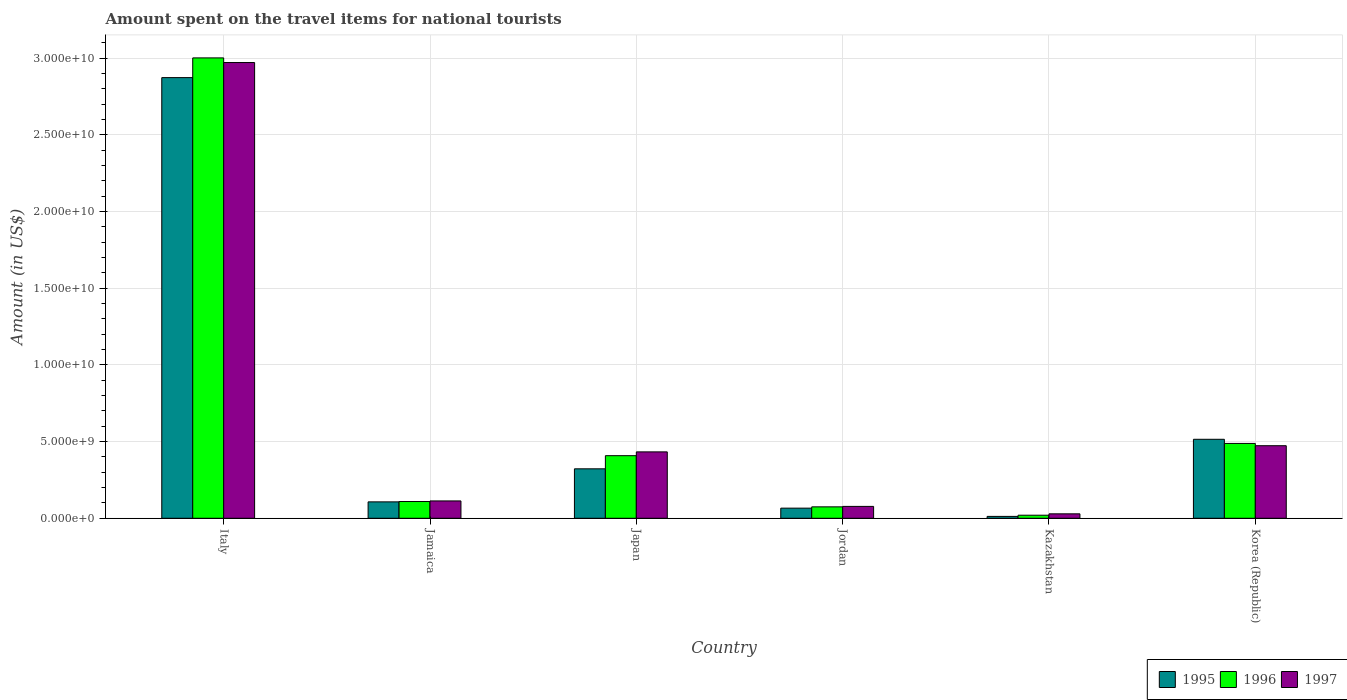How many different coloured bars are there?
Your response must be concise. 3. How many groups of bars are there?
Ensure brevity in your answer.  6. What is the label of the 5th group of bars from the left?
Keep it short and to the point. Kazakhstan. What is the amount spent on the travel items for national tourists in 1997 in Korea (Republic)?
Offer a very short reply. 4.73e+09. Across all countries, what is the maximum amount spent on the travel items for national tourists in 1997?
Provide a succinct answer. 2.97e+1. Across all countries, what is the minimum amount spent on the travel items for national tourists in 1997?
Make the answer very short. 2.89e+08. In which country was the amount spent on the travel items for national tourists in 1996 minimum?
Provide a succinct answer. Kazakhstan. What is the total amount spent on the travel items for national tourists in 1997 in the graph?
Offer a very short reply. 4.10e+1. What is the difference between the amount spent on the travel items for national tourists in 1996 in Italy and that in Japan?
Your response must be concise. 2.59e+1. What is the difference between the amount spent on the travel items for national tourists in 1997 in Kazakhstan and the amount spent on the travel items for national tourists in 1996 in Korea (Republic)?
Keep it short and to the point. -4.59e+09. What is the average amount spent on the travel items for national tourists in 1997 per country?
Offer a very short reply. 6.83e+09. What is the difference between the amount spent on the travel items for national tourists of/in 1997 and amount spent on the travel items for national tourists of/in 1996 in Kazakhstan?
Provide a short and direct response. 9.00e+07. What is the ratio of the amount spent on the travel items for national tourists in 1996 in Jamaica to that in Korea (Republic)?
Offer a terse response. 0.22. Is the amount spent on the travel items for national tourists in 1996 in Italy less than that in Kazakhstan?
Your response must be concise. No. Is the difference between the amount spent on the travel items for national tourists in 1997 in Kazakhstan and Korea (Republic) greater than the difference between the amount spent on the travel items for national tourists in 1996 in Kazakhstan and Korea (Republic)?
Give a very brief answer. Yes. What is the difference between the highest and the second highest amount spent on the travel items for national tourists in 1997?
Your answer should be very brief. 2.54e+1. What is the difference between the highest and the lowest amount spent on the travel items for national tourists in 1996?
Your answer should be compact. 2.98e+1. In how many countries, is the amount spent on the travel items for national tourists in 1995 greater than the average amount spent on the travel items for national tourists in 1995 taken over all countries?
Offer a very short reply. 1. What does the 1st bar from the right in Italy represents?
Keep it short and to the point. 1997. How many bars are there?
Your response must be concise. 18. What is the difference between two consecutive major ticks on the Y-axis?
Offer a very short reply. 5.00e+09. Are the values on the major ticks of Y-axis written in scientific E-notation?
Offer a very short reply. Yes. Does the graph contain any zero values?
Offer a terse response. No. Does the graph contain grids?
Offer a terse response. Yes. How many legend labels are there?
Ensure brevity in your answer.  3. What is the title of the graph?
Provide a short and direct response. Amount spent on the travel items for national tourists. What is the label or title of the X-axis?
Your answer should be very brief. Country. What is the Amount (in US$) of 1995 in Italy?
Ensure brevity in your answer.  2.87e+1. What is the Amount (in US$) in 1996 in Italy?
Give a very brief answer. 3.00e+1. What is the Amount (in US$) in 1997 in Italy?
Offer a very short reply. 2.97e+1. What is the Amount (in US$) of 1995 in Jamaica?
Give a very brief answer. 1.07e+09. What is the Amount (in US$) in 1996 in Jamaica?
Ensure brevity in your answer.  1.09e+09. What is the Amount (in US$) of 1997 in Jamaica?
Provide a short and direct response. 1.13e+09. What is the Amount (in US$) in 1995 in Japan?
Provide a short and direct response. 3.22e+09. What is the Amount (in US$) of 1996 in Japan?
Make the answer very short. 4.08e+09. What is the Amount (in US$) of 1997 in Japan?
Make the answer very short. 4.33e+09. What is the Amount (in US$) in 1995 in Jordan?
Ensure brevity in your answer.  6.60e+08. What is the Amount (in US$) in 1996 in Jordan?
Your answer should be compact. 7.44e+08. What is the Amount (in US$) of 1997 in Jordan?
Your response must be concise. 7.74e+08. What is the Amount (in US$) of 1995 in Kazakhstan?
Provide a succinct answer. 1.22e+08. What is the Amount (in US$) in 1996 in Kazakhstan?
Give a very brief answer. 1.99e+08. What is the Amount (in US$) in 1997 in Kazakhstan?
Keep it short and to the point. 2.89e+08. What is the Amount (in US$) in 1995 in Korea (Republic)?
Offer a very short reply. 5.15e+09. What is the Amount (in US$) of 1996 in Korea (Republic)?
Offer a terse response. 4.88e+09. What is the Amount (in US$) of 1997 in Korea (Republic)?
Provide a short and direct response. 4.73e+09. Across all countries, what is the maximum Amount (in US$) of 1995?
Your answer should be compact. 2.87e+1. Across all countries, what is the maximum Amount (in US$) of 1996?
Offer a very short reply. 3.00e+1. Across all countries, what is the maximum Amount (in US$) in 1997?
Make the answer very short. 2.97e+1. Across all countries, what is the minimum Amount (in US$) of 1995?
Offer a terse response. 1.22e+08. Across all countries, what is the minimum Amount (in US$) in 1996?
Make the answer very short. 1.99e+08. Across all countries, what is the minimum Amount (in US$) of 1997?
Ensure brevity in your answer.  2.89e+08. What is the total Amount (in US$) in 1995 in the graph?
Make the answer very short. 3.90e+1. What is the total Amount (in US$) of 1996 in the graph?
Your response must be concise. 4.10e+1. What is the total Amount (in US$) of 1997 in the graph?
Offer a very short reply. 4.10e+1. What is the difference between the Amount (in US$) of 1995 in Italy and that in Jamaica?
Keep it short and to the point. 2.77e+1. What is the difference between the Amount (in US$) of 1996 in Italy and that in Jamaica?
Offer a very short reply. 2.89e+1. What is the difference between the Amount (in US$) of 1997 in Italy and that in Jamaica?
Provide a short and direct response. 2.86e+1. What is the difference between the Amount (in US$) in 1995 in Italy and that in Japan?
Offer a terse response. 2.55e+1. What is the difference between the Amount (in US$) in 1996 in Italy and that in Japan?
Provide a succinct answer. 2.59e+1. What is the difference between the Amount (in US$) of 1997 in Italy and that in Japan?
Keep it short and to the point. 2.54e+1. What is the difference between the Amount (in US$) in 1995 in Italy and that in Jordan?
Provide a succinct answer. 2.81e+1. What is the difference between the Amount (in US$) in 1996 in Italy and that in Jordan?
Your response must be concise. 2.93e+1. What is the difference between the Amount (in US$) of 1997 in Italy and that in Jordan?
Give a very brief answer. 2.89e+1. What is the difference between the Amount (in US$) of 1995 in Italy and that in Kazakhstan?
Keep it short and to the point. 2.86e+1. What is the difference between the Amount (in US$) of 1996 in Italy and that in Kazakhstan?
Provide a succinct answer. 2.98e+1. What is the difference between the Amount (in US$) of 1997 in Italy and that in Kazakhstan?
Your answer should be very brief. 2.94e+1. What is the difference between the Amount (in US$) of 1995 in Italy and that in Korea (Republic)?
Provide a succinct answer. 2.36e+1. What is the difference between the Amount (in US$) in 1996 in Italy and that in Korea (Republic)?
Your answer should be very brief. 2.51e+1. What is the difference between the Amount (in US$) of 1997 in Italy and that in Korea (Republic)?
Ensure brevity in your answer.  2.50e+1. What is the difference between the Amount (in US$) in 1995 in Jamaica and that in Japan?
Offer a very short reply. -2.16e+09. What is the difference between the Amount (in US$) in 1996 in Jamaica and that in Japan?
Give a very brief answer. -2.99e+09. What is the difference between the Amount (in US$) in 1997 in Jamaica and that in Japan?
Give a very brief answer. -3.20e+09. What is the difference between the Amount (in US$) in 1995 in Jamaica and that in Jordan?
Give a very brief answer. 4.09e+08. What is the difference between the Amount (in US$) in 1996 in Jamaica and that in Jordan?
Make the answer very short. 3.48e+08. What is the difference between the Amount (in US$) in 1997 in Jamaica and that in Jordan?
Ensure brevity in your answer.  3.57e+08. What is the difference between the Amount (in US$) in 1995 in Jamaica and that in Kazakhstan?
Offer a terse response. 9.47e+08. What is the difference between the Amount (in US$) of 1996 in Jamaica and that in Kazakhstan?
Ensure brevity in your answer.  8.93e+08. What is the difference between the Amount (in US$) of 1997 in Jamaica and that in Kazakhstan?
Give a very brief answer. 8.42e+08. What is the difference between the Amount (in US$) in 1995 in Jamaica and that in Korea (Republic)?
Provide a short and direct response. -4.08e+09. What is the difference between the Amount (in US$) in 1996 in Jamaica and that in Korea (Republic)?
Your answer should be compact. -3.79e+09. What is the difference between the Amount (in US$) of 1997 in Jamaica and that in Korea (Republic)?
Your answer should be very brief. -3.60e+09. What is the difference between the Amount (in US$) in 1995 in Japan and that in Jordan?
Offer a very short reply. 2.56e+09. What is the difference between the Amount (in US$) in 1996 in Japan and that in Jordan?
Your response must be concise. 3.34e+09. What is the difference between the Amount (in US$) of 1997 in Japan and that in Jordan?
Your response must be concise. 3.56e+09. What is the difference between the Amount (in US$) of 1995 in Japan and that in Kazakhstan?
Make the answer very short. 3.10e+09. What is the difference between the Amount (in US$) in 1996 in Japan and that in Kazakhstan?
Your answer should be compact. 3.88e+09. What is the difference between the Amount (in US$) in 1997 in Japan and that in Kazakhstan?
Ensure brevity in your answer.  4.04e+09. What is the difference between the Amount (in US$) in 1995 in Japan and that in Korea (Republic)?
Make the answer very short. -1.93e+09. What is the difference between the Amount (in US$) of 1996 in Japan and that in Korea (Republic)?
Offer a terse response. -7.99e+08. What is the difference between the Amount (in US$) of 1997 in Japan and that in Korea (Republic)?
Offer a very short reply. -4.02e+08. What is the difference between the Amount (in US$) of 1995 in Jordan and that in Kazakhstan?
Ensure brevity in your answer.  5.38e+08. What is the difference between the Amount (in US$) of 1996 in Jordan and that in Kazakhstan?
Make the answer very short. 5.45e+08. What is the difference between the Amount (in US$) of 1997 in Jordan and that in Kazakhstan?
Keep it short and to the point. 4.85e+08. What is the difference between the Amount (in US$) in 1995 in Jordan and that in Korea (Republic)?
Ensure brevity in your answer.  -4.49e+09. What is the difference between the Amount (in US$) in 1996 in Jordan and that in Korea (Republic)?
Keep it short and to the point. -4.14e+09. What is the difference between the Amount (in US$) in 1997 in Jordan and that in Korea (Republic)?
Ensure brevity in your answer.  -3.96e+09. What is the difference between the Amount (in US$) of 1995 in Kazakhstan and that in Korea (Republic)?
Offer a very short reply. -5.03e+09. What is the difference between the Amount (in US$) in 1996 in Kazakhstan and that in Korea (Republic)?
Offer a very short reply. -4.68e+09. What is the difference between the Amount (in US$) of 1997 in Kazakhstan and that in Korea (Republic)?
Your response must be concise. -4.44e+09. What is the difference between the Amount (in US$) of 1995 in Italy and the Amount (in US$) of 1996 in Jamaica?
Provide a succinct answer. 2.76e+1. What is the difference between the Amount (in US$) of 1995 in Italy and the Amount (in US$) of 1997 in Jamaica?
Make the answer very short. 2.76e+1. What is the difference between the Amount (in US$) of 1996 in Italy and the Amount (in US$) of 1997 in Jamaica?
Offer a terse response. 2.89e+1. What is the difference between the Amount (in US$) in 1995 in Italy and the Amount (in US$) in 1996 in Japan?
Make the answer very short. 2.46e+1. What is the difference between the Amount (in US$) in 1995 in Italy and the Amount (in US$) in 1997 in Japan?
Your answer should be compact. 2.44e+1. What is the difference between the Amount (in US$) in 1996 in Italy and the Amount (in US$) in 1997 in Japan?
Offer a terse response. 2.57e+1. What is the difference between the Amount (in US$) in 1995 in Italy and the Amount (in US$) in 1996 in Jordan?
Your answer should be compact. 2.80e+1. What is the difference between the Amount (in US$) in 1995 in Italy and the Amount (in US$) in 1997 in Jordan?
Keep it short and to the point. 2.80e+1. What is the difference between the Amount (in US$) in 1996 in Italy and the Amount (in US$) in 1997 in Jordan?
Your answer should be very brief. 2.92e+1. What is the difference between the Amount (in US$) in 1995 in Italy and the Amount (in US$) in 1996 in Kazakhstan?
Make the answer very short. 2.85e+1. What is the difference between the Amount (in US$) of 1995 in Italy and the Amount (in US$) of 1997 in Kazakhstan?
Ensure brevity in your answer.  2.84e+1. What is the difference between the Amount (in US$) of 1996 in Italy and the Amount (in US$) of 1997 in Kazakhstan?
Your answer should be very brief. 2.97e+1. What is the difference between the Amount (in US$) in 1995 in Italy and the Amount (in US$) in 1996 in Korea (Republic)?
Make the answer very short. 2.39e+1. What is the difference between the Amount (in US$) of 1995 in Italy and the Amount (in US$) of 1997 in Korea (Republic)?
Give a very brief answer. 2.40e+1. What is the difference between the Amount (in US$) of 1996 in Italy and the Amount (in US$) of 1997 in Korea (Republic)?
Make the answer very short. 2.53e+1. What is the difference between the Amount (in US$) in 1995 in Jamaica and the Amount (in US$) in 1996 in Japan?
Provide a succinct answer. -3.01e+09. What is the difference between the Amount (in US$) of 1995 in Jamaica and the Amount (in US$) of 1997 in Japan?
Your answer should be compact. -3.26e+09. What is the difference between the Amount (in US$) in 1996 in Jamaica and the Amount (in US$) in 1997 in Japan?
Make the answer very short. -3.24e+09. What is the difference between the Amount (in US$) of 1995 in Jamaica and the Amount (in US$) of 1996 in Jordan?
Your answer should be very brief. 3.25e+08. What is the difference between the Amount (in US$) in 1995 in Jamaica and the Amount (in US$) in 1997 in Jordan?
Your answer should be compact. 2.95e+08. What is the difference between the Amount (in US$) of 1996 in Jamaica and the Amount (in US$) of 1997 in Jordan?
Give a very brief answer. 3.18e+08. What is the difference between the Amount (in US$) in 1995 in Jamaica and the Amount (in US$) in 1996 in Kazakhstan?
Ensure brevity in your answer.  8.70e+08. What is the difference between the Amount (in US$) of 1995 in Jamaica and the Amount (in US$) of 1997 in Kazakhstan?
Make the answer very short. 7.80e+08. What is the difference between the Amount (in US$) in 1996 in Jamaica and the Amount (in US$) in 1997 in Kazakhstan?
Offer a terse response. 8.03e+08. What is the difference between the Amount (in US$) in 1995 in Jamaica and the Amount (in US$) in 1996 in Korea (Republic)?
Ensure brevity in your answer.  -3.81e+09. What is the difference between the Amount (in US$) in 1995 in Jamaica and the Amount (in US$) in 1997 in Korea (Republic)?
Offer a very short reply. -3.66e+09. What is the difference between the Amount (in US$) of 1996 in Jamaica and the Amount (in US$) of 1997 in Korea (Republic)?
Provide a short and direct response. -3.64e+09. What is the difference between the Amount (in US$) of 1995 in Japan and the Amount (in US$) of 1996 in Jordan?
Your answer should be compact. 2.48e+09. What is the difference between the Amount (in US$) in 1995 in Japan and the Amount (in US$) in 1997 in Jordan?
Keep it short and to the point. 2.45e+09. What is the difference between the Amount (in US$) of 1996 in Japan and the Amount (in US$) of 1997 in Jordan?
Your response must be concise. 3.31e+09. What is the difference between the Amount (in US$) in 1995 in Japan and the Amount (in US$) in 1996 in Kazakhstan?
Give a very brief answer. 3.02e+09. What is the difference between the Amount (in US$) of 1995 in Japan and the Amount (in US$) of 1997 in Kazakhstan?
Your answer should be compact. 2.94e+09. What is the difference between the Amount (in US$) of 1996 in Japan and the Amount (in US$) of 1997 in Kazakhstan?
Your answer should be very brief. 3.79e+09. What is the difference between the Amount (in US$) in 1995 in Japan and the Amount (in US$) in 1996 in Korea (Republic)?
Offer a terse response. -1.66e+09. What is the difference between the Amount (in US$) of 1995 in Japan and the Amount (in US$) of 1997 in Korea (Republic)?
Your answer should be compact. -1.51e+09. What is the difference between the Amount (in US$) of 1996 in Japan and the Amount (in US$) of 1997 in Korea (Republic)?
Your response must be concise. -6.50e+08. What is the difference between the Amount (in US$) in 1995 in Jordan and the Amount (in US$) in 1996 in Kazakhstan?
Offer a very short reply. 4.61e+08. What is the difference between the Amount (in US$) in 1995 in Jordan and the Amount (in US$) in 1997 in Kazakhstan?
Offer a terse response. 3.71e+08. What is the difference between the Amount (in US$) in 1996 in Jordan and the Amount (in US$) in 1997 in Kazakhstan?
Your response must be concise. 4.55e+08. What is the difference between the Amount (in US$) in 1995 in Jordan and the Amount (in US$) in 1996 in Korea (Republic)?
Provide a short and direct response. -4.22e+09. What is the difference between the Amount (in US$) of 1995 in Jordan and the Amount (in US$) of 1997 in Korea (Republic)?
Offer a terse response. -4.07e+09. What is the difference between the Amount (in US$) of 1996 in Jordan and the Amount (in US$) of 1997 in Korea (Republic)?
Make the answer very short. -3.99e+09. What is the difference between the Amount (in US$) of 1995 in Kazakhstan and the Amount (in US$) of 1996 in Korea (Republic)?
Your answer should be compact. -4.76e+09. What is the difference between the Amount (in US$) in 1995 in Kazakhstan and the Amount (in US$) in 1997 in Korea (Republic)?
Give a very brief answer. -4.61e+09. What is the difference between the Amount (in US$) in 1996 in Kazakhstan and the Amount (in US$) in 1997 in Korea (Republic)?
Offer a terse response. -4.53e+09. What is the average Amount (in US$) in 1995 per country?
Offer a very short reply. 6.49e+09. What is the average Amount (in US$) of 1996 per country?
Your answer should be very brief. 6.84e+09. What is the average Amount (in US$) in 1997 per country?
Offer a terse response. 6.83e+09. What is the difference between the Amount (in US$) in 1995 and Amount (in US$) in 1996 in Italy?
Offer a very short reply. -1.29e+09. What is the difference between the Amount (in US$) of 1995 and Amount (in US$) of 1997 in Italy?
Keep it short and to the point. -9.83e+08. What is the difference between the Amount (in US$) in 1996 and Amount (in US$) in 1997 in Italy?
Your answer should be compact. 3.03e+08. What is the difference between the Amount (in US$) of 1995 and Amount (in US$) of 1996 in Jamaica?
Provide a short and direct response. -2.30e+07. What is the difference between the Amount (in US$) in 1995 and Amount (in US$) in 1997 in Jamaica?
Provide a short and direct response. -6.20e+07. What is the difference between the Amount (in US$) of 1996 and Amount (in US$) of 1997 in Jamaica?
Give a very brief answer. -3.90e+07. What is the difference between the Amount (in US$) of 1995 and Amount (in US$) of 1996 in Japan?
Provide a succinct answer. -8.57e+08. What is the difference between the Amount (in US$) in 1995 and Amount (in US$) in 1997 in Japan?
Make the answer very short. -1.10e+09. What is the difference between the Amount (in US$) in 1996 and Amount (in US$) in 1997 in Japan?
Offer a very short reply. -2.48e+08. What is the difference between the Amount (in US$) in 1995 and Amount (in US$) in 1996 in Jordan?
Offer a terse response. -8.40e+07. What is the difference between the Amount (in US$) in 1995 and Amount (in US$) in 1997 in Jordan?
Your response must be concise. -1.14e+08. What is the difference between the Amount (in US$) of 1996 and Amount (in US$) of 1997 in Jordan?
Your answer should be compact. -3.00e+07. What is the difference between the Amount (in US$) of 1995 and Amount (in US$) of 1996 in Kazakhstan?
Provide a short and direct response. -7.70e+07. What is the difference between the Amount (in US$) of 1995 and Amount (in US$) of 1997 in Kazakhstan?
Offer a very short reply. -1.67e+08. What is the difference between the Amount (in US$) of 1996 and Amount (in US$) of 1997 in Kazakhstan?
Provide a short and direct response. -9.00e+07. What is the difference between the Amount (in US$) in 1995 and Amount (in US$) in 1996 in Korea (Republic)?
Make the answer very short. 2.70e+08. What is the difference between the Amount (in US$) of 1995 and Amount (in US$) of 1997 in Korea (Republic)?
Provide a succinct answer. 4.19e+08. What is the difference between the Amount (in US$) of 1996 and Amount (in US$) of 1997 in Korea (Republic)?
Your answer should be compact. 1.49e+08. What is the ratio of the Amount (in US$) of 1995 in Italy to that in Jamaica?
Offer a terse response. 26.88. What is the ratio of the Amount (in US$) of 1996 in Italy to that in Jamaica?
Provide a succinct answer. 27.49. What is the ratio of the Amount (in US$) in 1997 in Italy to that in Jamaica?
Offer a very short reply. 26.27. What is the ratio of the Amount (in US$) in 1995 in Italy to that in Japan?
Keep it short and to the point. 8.91. What is the ratio of the Amount (in US$) of 1996 in Italy to that in Japan?
Provide a succinct answer. 7.36. What is the ratio of the Amount (in US$) of 1997 in Italy to that in Japan?
Your answer should be very brief. 6.86. What is the ratio of the Amount (in US$) in 1995 in Italy to that in Jordan?
Your answer should be compact. 43.53. What is the ratio of the Amount (in US$) in 1996 in Italy to that in Jordan?
Give a very brief answer. 40.35. What is the ratio of the Amount (in US$) in 1997 in Italy to that in Jordan?
Offer a terse response. 38.39. What is the ratio of the Amount (in US$) of 1995 in Italy to that in Kazakhstan?
Offer a very short reply. 235.5. What is the ratio of the Amount (in US$) of 1996 in Italy to that in Kazakhstan?
Provide a short and direct response. 150.84. What is the ratio of the Amount (in US$) of 1997 in Italy to that in Kazakhstan?
Ensure brevity in your answer.  102.82. What is the ratio of the Amount (in US$) in 1995 in Italy to that in Korea (Republic)?
Make the answer very short. 5.58. What is the ratio of the Amount (in US$) in 1996 in Italy to that in Korea (Republic)?
Your response must be concise. 6.15. What is the ratio of the Amount (in US$) of 1997 in Italy to that in Korea (Republic)?
Offer a very short reply. 6.28. What is the ratio of the Amount (in US$) in 1995 in Jamaica to that in Japan?
Provide a succinct answer. 0.33. What is the ratio of the Amount (in US$) in 1996 in Jamaica to that in Japan?
Your answer should be very brief. 0.27. What is the ratio of the Amount (in US$) of 1997 in Jamaica to that in Japan?
Make the answer very short. 0.26. What is the ratio of the Amount (in US$) in 1995 in Jamaica to that in Jordan?
Your answer should be very brief. 1.62. What is the ratio of the Amount (in US$) of 1996 in Jamaica to that in Jordan?
Your answer should be compact. 1.47. What is the ratio of the Amount (in US$) in 1997 in Jamaica to that in Jordan?
Your response must be concise. 1.46. What is the ratio of the Amount (in US$) in 1995 in Jamaica to that in Kazakhstan?
Give a very brief answer. 8.76. What is the ratio of the Amount (in US$) in 1996 in Jamaica to that in Kazakhstan?
Provide a succinct answer. 5.49. What is the ratio of the Amount (in US$) in 1997 in Jamaica to that in Kazakhstan?
Your response must be concise. 3.91. What is the ratio of the Amount (in US$) of 1995 in Jamaica to that in Korea (Republic)?
Make the answer very short. 0.21. What is the ratio of the Amount (in US$) of 1996 in Jamaica to that in Korea (Republic)?
Your answer should be compact. 0.22. What is the ratio of the Amount (in US$) of 1997 in Jamaica to that in Korea (Republic)?
Provide a succinct answer. 0.24. What is the ratio of the Amount (in US$) in 1995 in Japan to that in Jordan?
Your response must be concise. 4.88. What is the ratio of the Amount (in US$) in 1996 in Japan to that in Jordan?
Keep it short and to the point. 5.49. What is the ratio of the Amount (in US$) of 1997 in Japan to that in Jordan?
Keep it short and to the point. 5.59. What is the ratio of the Amount (in US$) of 1995 in Japan to that in Kazakhstan?
Offer a very short reply. 26.43. What is the ratio of the Amount (in US$) of 1996 in Japan to that in Kazakhstan?
Provide a short and direct response. 20.51. What is the ratio of the Amount (in US$) of 1997 in Japan to that in Kazakhstan?
Give a very brief answer. 14.98. What is the ratio of the Amount (in US$) of 1995 in Japan to that in Korea (Republic)?
Offer a terse response. 0.63. What is the ratio of the Amount (in US$) in 1996 in Japan to that in Korea (Republic)?
Your answer should be very brief. 0.84. What is the ratio of the Amount (in US$) of 1997 in Japan to that in Korea (Republic)?
Your answer should be very brief. 0.92. What is the ratio of the Amount (in US$) of 1995 in Jordan to that in Kazakhstan?
Ensure brevity in your answer.  5.41. What is the ratio of the Amount (in US$) of 1996 in Jordan to that in Kazakhstan?
Keep it short and to the point. 3.74. What is the ratio of the Amount (in US$) of 1997 in Jordan to that in Kazakhstan?
Ensure brevity in your answer.  2.68. What is the ratio of the Amount (in US$) of 1995 in Jordan to that in Korea (Republic)?
Give a very brief answer. 0.13. What is the ratio of the Amount (in US$) in 1996 in Jordan to that in Korea (Republic)?
Your answer should be very brief. 0.15. What is the ratio of the Amount (in US$) in 1997 in Jordan to that in Korea (Republic)?
Your response must be concise. 0.16. What is the ratio of the Amount (in US$) of 1995 in Kazakhstan to that in Korea (Republic)?
Give a very brief answer. 0.02. What is the ratio of the Amount (in US$) of 1996 in Kazakhstan to that in Korea (Republic)?
Provide a short and direct response. 0.04. What is the ratio of the Amount (in US$) of 1997 in Kazakhstan to that in Korea (Republic)?
Your answer should be compact. 0.06. What is the difference between the highest and the second highest Amount (in US$) in 1995?
Your answer should be very brief. 2.36e+1. What is the difference between the highest and the second highest Amount (in US$) in 1996?
Make the answer very short. 2.51e+1. What is the difference between the highest and the second highest Amount (in US$) in 1997?
Your response must be concise. 2.50e+1. What is the difference between the highest and the lowest Amount (in US$) of 1995?
Make the answer very short. 2.86e+1. What is the difference between the highest and the lowest Amount (in US$) of 1996?
Provide a short and direct response. 2.98e+1. What is the difference between the highest and the lowest Amount (in US$) in 1997?
Make the answer very short. 2.94e+1. 